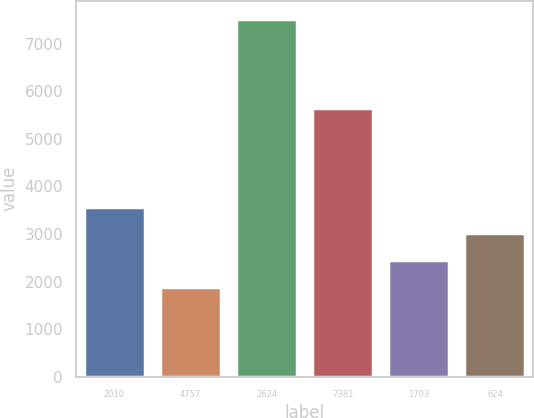<chart> <loc_0><loc_0><loc_500><loc_500><bar_chart><fcel>2010<fcel>4757<fcel>2624<fcel>7381<fcel>1703<fcel>624<nl><fcel>3575.3<fcel>1883<fcel>7524<fcel>5641<fcel>2447.1<fcel>3011.2<nl></chart> 